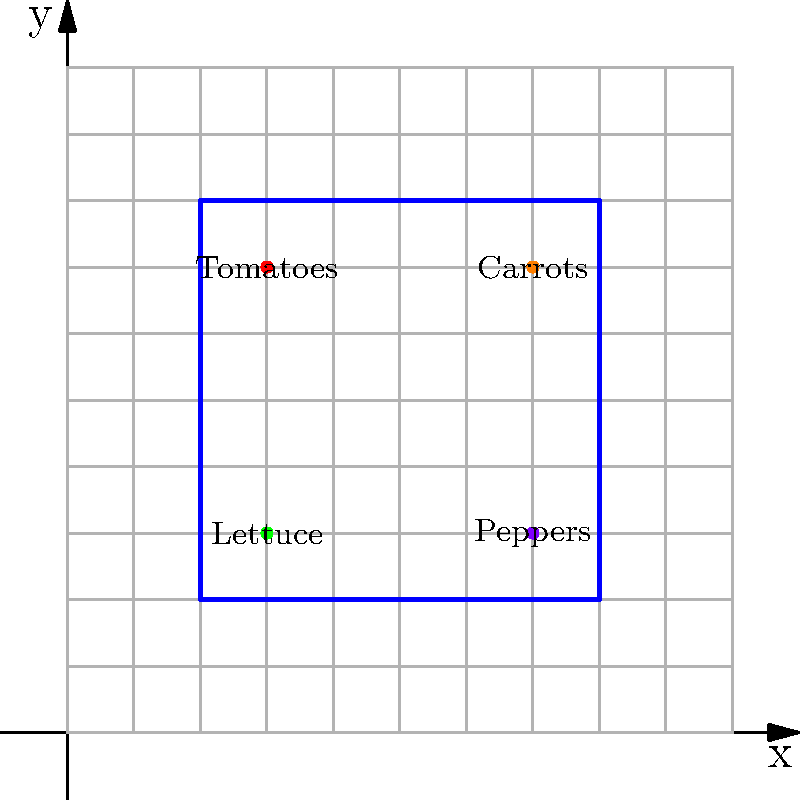You want to create a vegetable garden with your kids as a fun weekend project. You decide to use a coordinate plane to plan the layout. The garden plot is represented by a square with corners at (2,2), (8,2), (8,8), and (2,8). You place tomatoes at (3,7), carrots at (7,7), lettuce at (3,3), and peppers at (7,3). What is the total area of the garden plot in square units? To find the area of the garden plot, we need to follow these steps:

1. Identify the shape of the garden plot:
   The plot is a square with corners at (2,2), (8,2), (8,8), and (2,8).

2. Calculate the length of one side of the square:
   We can find this by subtracting the x-coordinates or y-coordinates of two opposite corners.
   Side length = 8 - 2 = 6 units

3. Calculate the area of the square:
   Area of a square = side length × side length
   Area = 6 × 6 = 36 square units

Therefore, the total area of the garden plot is 36 square units.

Note: The positions of the vegetables (tomatoes, carrots, lettuce, and peppers) don't affect the calculation of the garden's total area. They are included to make the activity more engaging and educational for the children.
Answer: 36 square units 